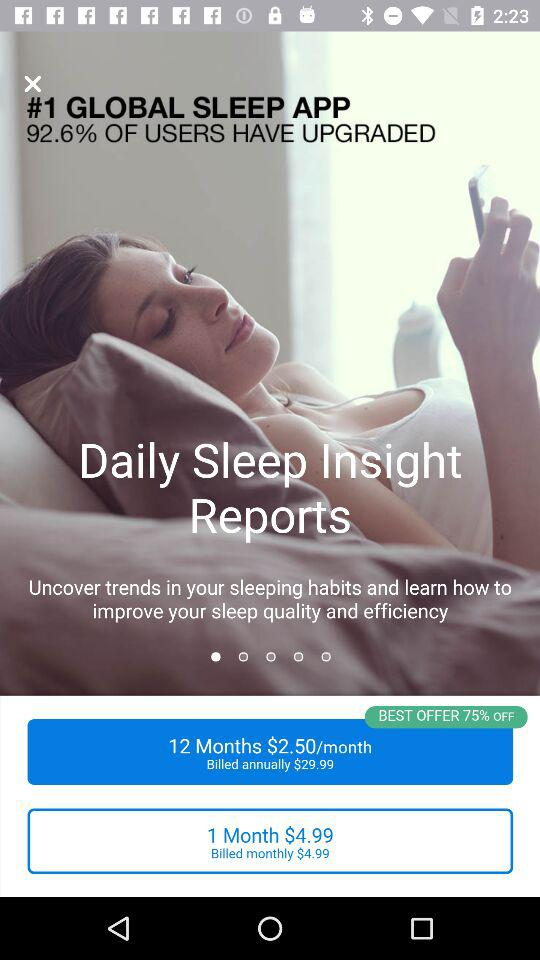What is the amount per month for 12 months? The amount is $2.50/month. 